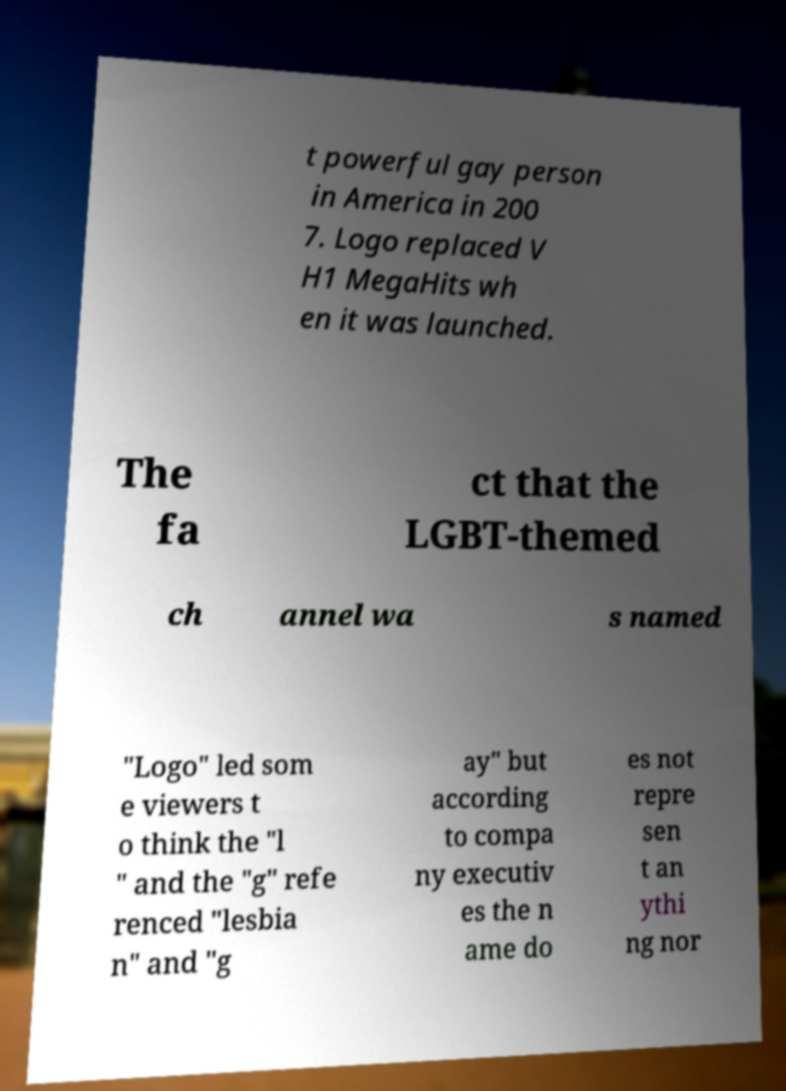There's text embedded in this image that I need extracted. Can you transcribe it verbatim? t powerful gay person in America in 200 7. Logo replaced V H1 MegaHits wh en it was launched. The fa ct that the LGBT-themed ch annel wa s named "Logo" led som e viewers t o think the "l " and the "g" refe renced "lesbia n" and "g ay" but according to compa ny executiv es the n ame do es not repre sen t an ythi ng nor 